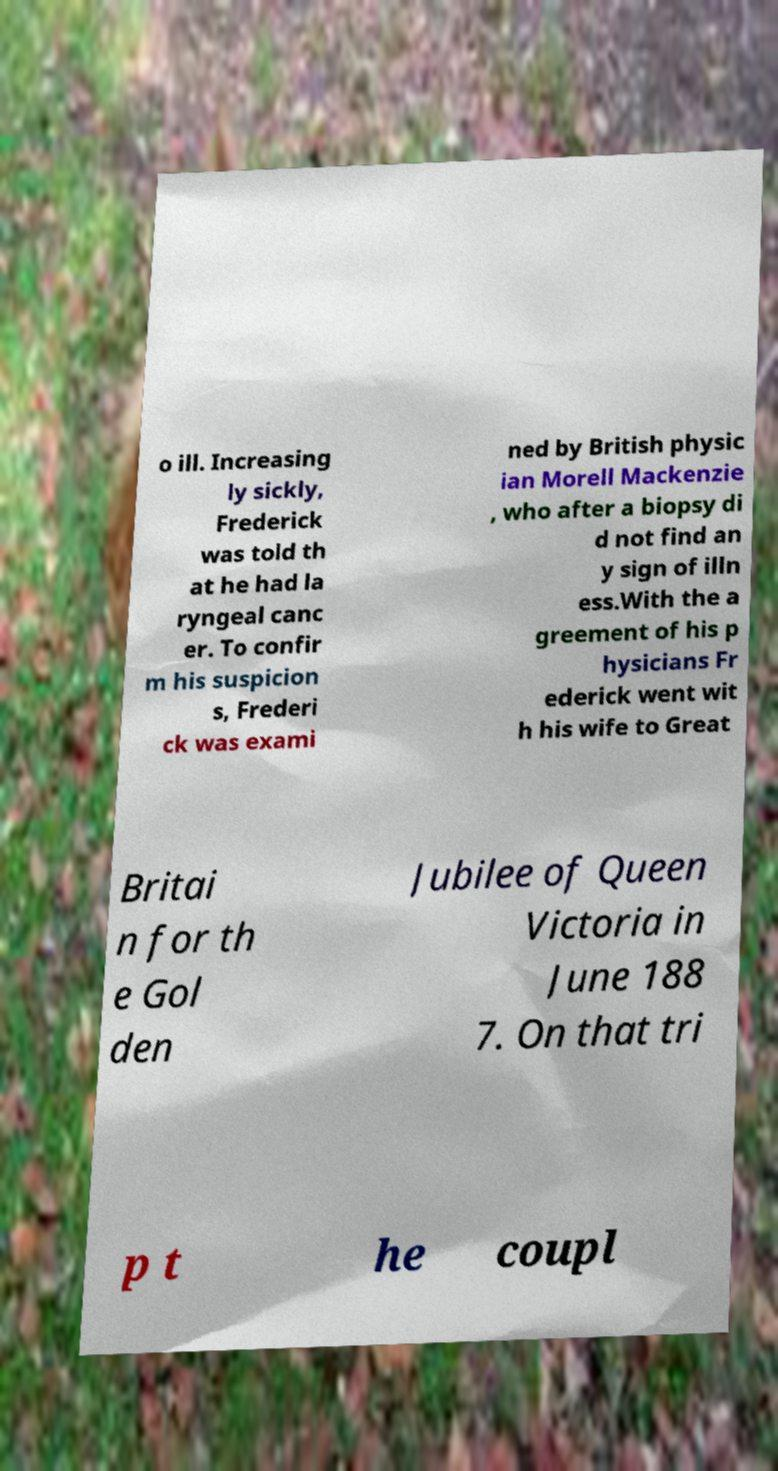For documentation purposes, I need the text within this image transcribed. Could you provide that? o ill. Increasing ly sickly, Frederick was told th at he had la ryngeal canc er. To confir m his suspicion s, Frederi ck was exami ned by British physic ian Morell Mackenzie , who after a biopsy di d not find an y sign of illn ess.With the a greement of his p hysicians Fr ederick went wit h his wife to Great Britai n for th e Gol den Jubilee of Queen Victoria in June 188 7. On that tri p t he coupl 